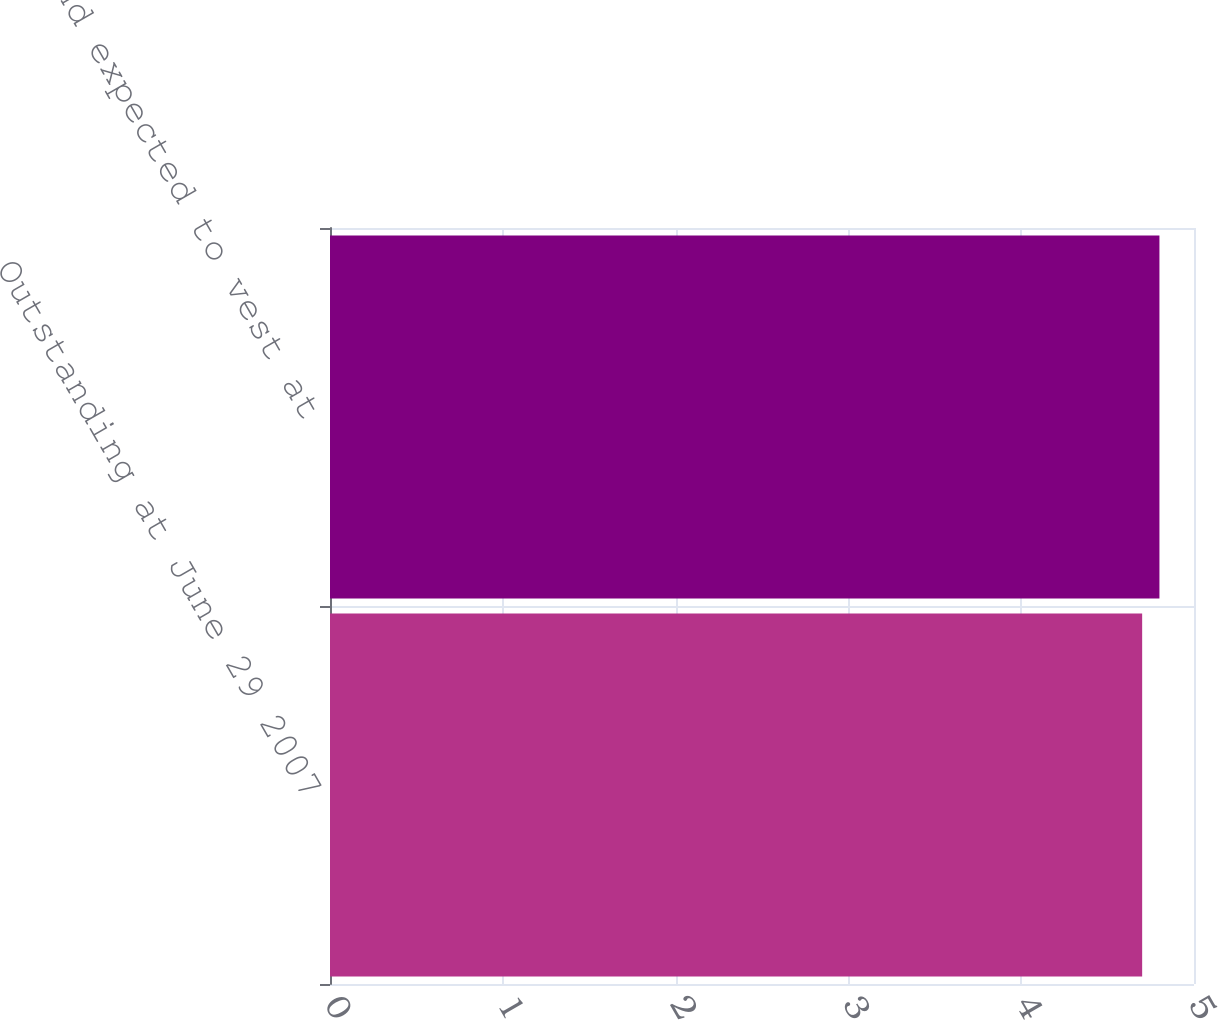Convert chart to OTSL. <chart><loc_0><loc_0><loc_500><loc_500><bar_chart><fcel>Outstanding at June 29 2007<fcel>Vested and expected to vest at<nl><fcel>4.7<fcel>4.8<nl></chart> 